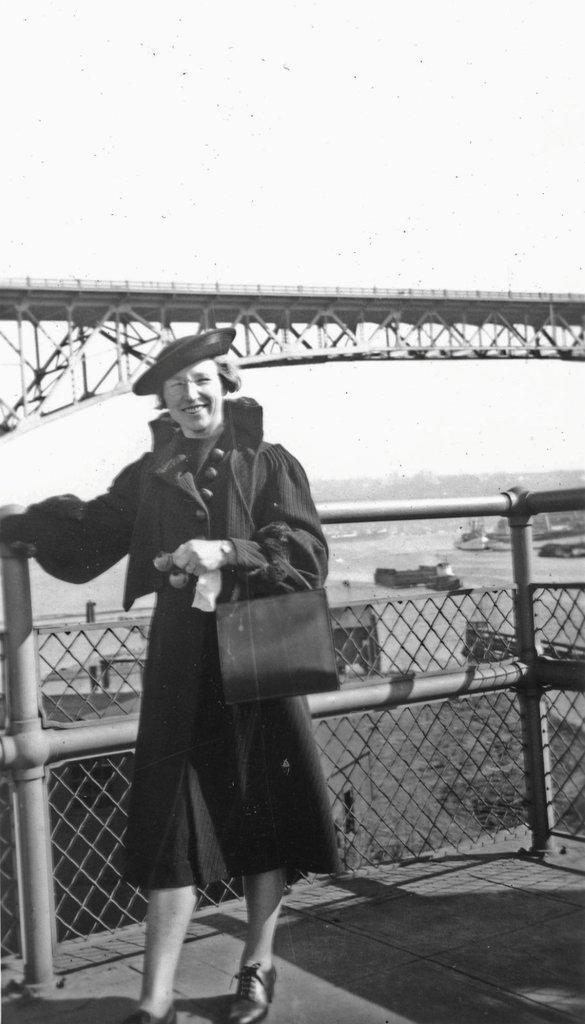What is the color scheme of the image? The image is black and white. Who is present in the image? There is a woman in the image. What is the woman's expression? The woman is smiling. What is the woman wearing on her head? The woman is wearing a hat. What can be seen in the background of the image? There is a fence, boats, water, and the sky visible in the background of the image. What type of development can be seen in the image? There is no development visible in the image; it is a black and white photograph of a woman wearing a hat and smiling. How does the image demonstrate respect? The image does not demonstrate respect; it is a simple photograph of a woman. 